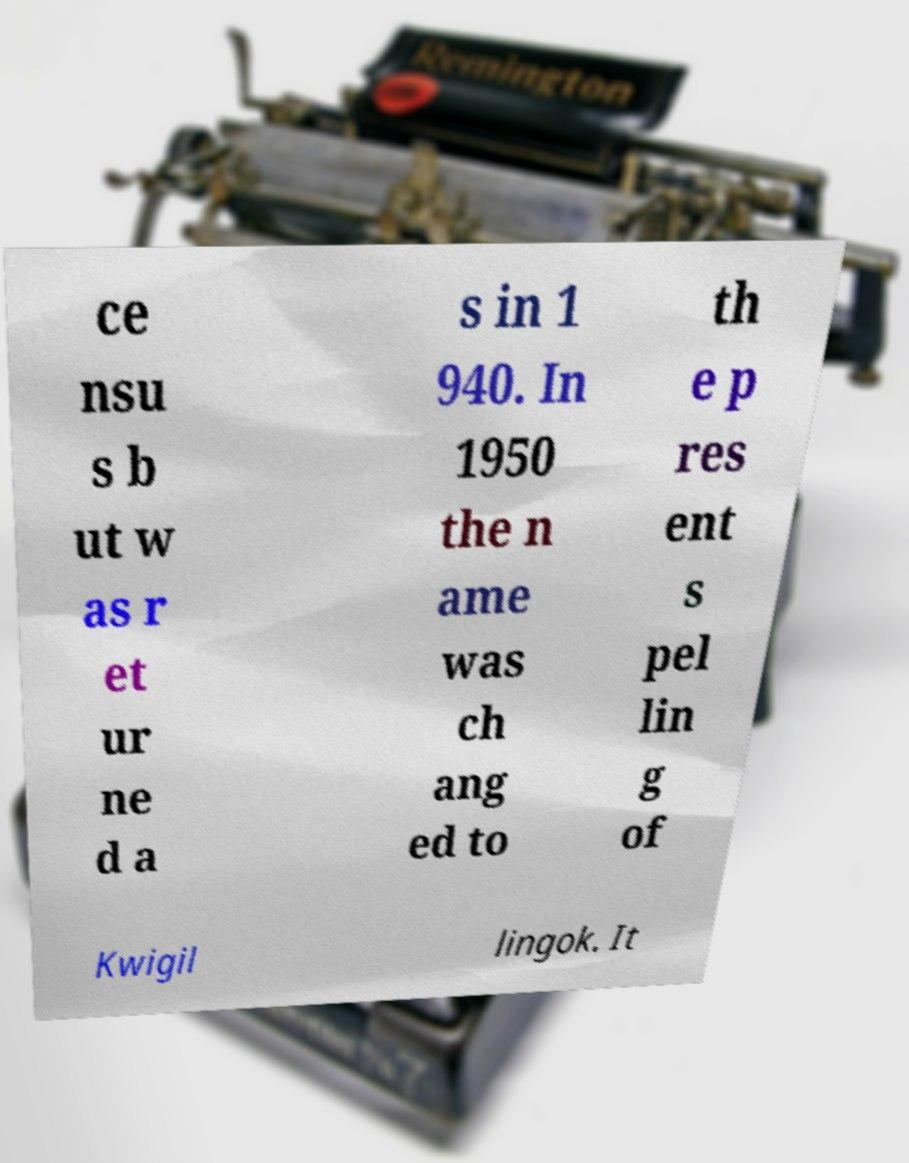Can you accurately transcribe the text from the provided image for me? ce nsu s b ut w as r et ur ne d a s in 1 940. In 1950 the n ame was ch ang ed to th e p res ent s pel lin g of Kwigil lingok. It 